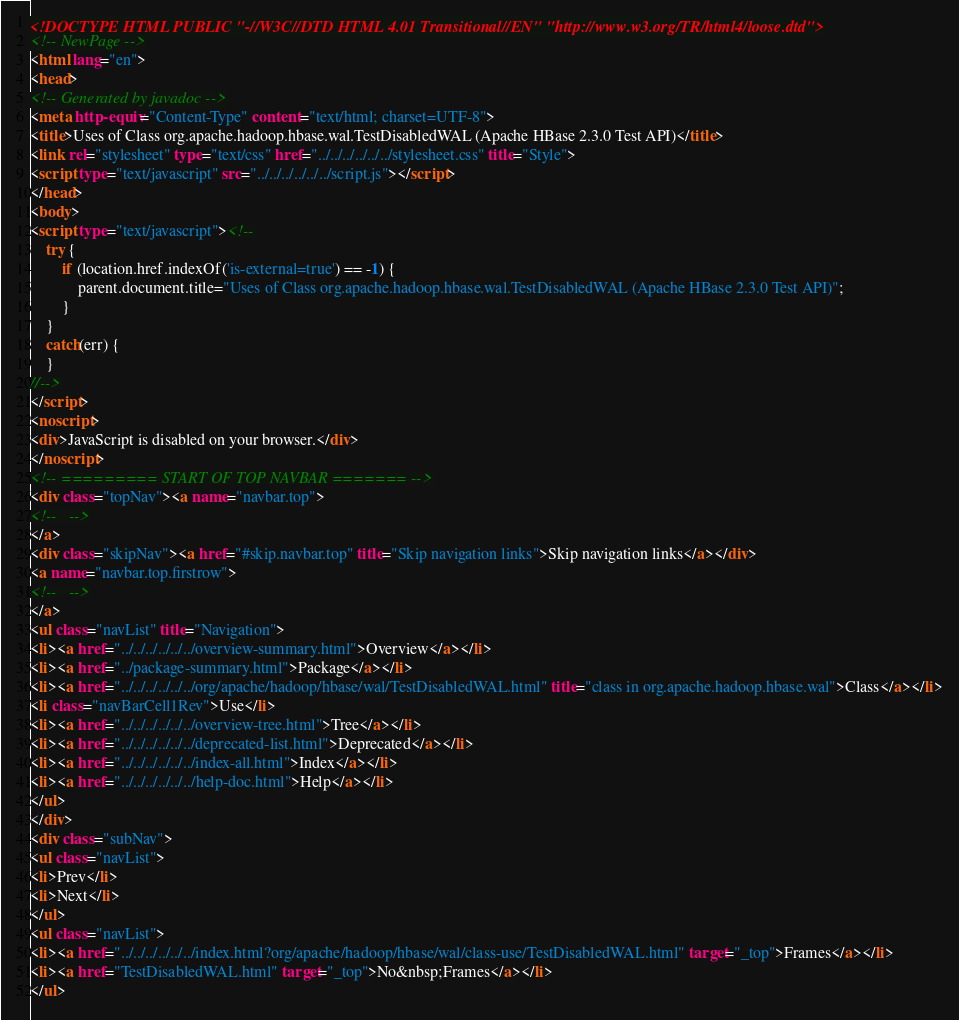<code> <loc_0><loc_0><loc_500><loc_500><_HTML_><!DOCTYPE HTML PUBLIC "-//W3C//DTD HTML 4.01 Transitional//EN" "http://www.w3.org/TR/html4/loose.dtd">
<!-- NewPage -->
<html lang="en">
<head>
<!-- Generated by javadoc -->
<meta http-equiv="Content-Type" content="text/html; charset=UTF-8">
<title>Uses of Class org.apache.hadoop.hbase.wal.TestDisabledWAL (Apache HBase 2.3.0 Test API)</title>
<link rel="stylesheet" type="text/css" href="../../../../../../stylesheet.css" title="Style">
<script type="text/javascript" src="../../../../../../script.js"></script>
</head>
<body>
<script type="text/javascript"><!--
    try {
        if (location.href.indexOf('is-external=true') == -1) {
            parent.document.title="Uses of Class org.apache.hadoop.hbase.wal.TestDisabledWAL (Apache HBase 2.3.0 Test API)";
        }
    }
    catch(err) {
    }
//-->
</script>
<noscript>
<div>JavaScript is disabled on your browser.</div>
</noscript>
<!-- ========= START OF TOP NAVBAR ======= -->
<div class="topNav"><a name="navbar.top">
<!--   -->
</a>
<div class="skipNav"><a href="#skip.navbar.top" title="Skip navigation links">Skip navigation links</a></div>
<a name="navbar.top.firstrow">
<!--   -->
</a>
<ul class="navList" title="Navigation">
<li><a href="../../../../../../overview-summary.html">Overview</a></li>
<li><a href="../package-summary.html">Package</a></li>
<li><a href="../../../../../../org/apache/hadoop/hbase/wal/TestDisabledWAL.html" title="class in org.apache.hadoop.hbase.wal">Class</a></li>
<li class="navBarCell1Rev">Use</li>
<li><a href="../../../../../../overview-tree.html">Tree</a></li>
<li><a href="../../../../../../deprecated-list.html">Deprecated</a></li>
<li><a href="../../../../../../index-all.html">Index</a></li>
<li><a href="../../../../../../help-doc.html">Help</a></li>
</ul>
</div>
<div class="subNav">
<ul class="navList">
<li>Prev</li>
<li>Next</li>
</ul>
<ul class="navList">
<li><a href="../../../../../../index.html?org/apache/hadoop/hbase/wal/class-use/TestDisabledWAL.html" target="_top">Frames</a></li>
<li><a href="TestDisabledWAL.html" target="_top">No&nbsp;Frames</a></li>
</ul></code> 